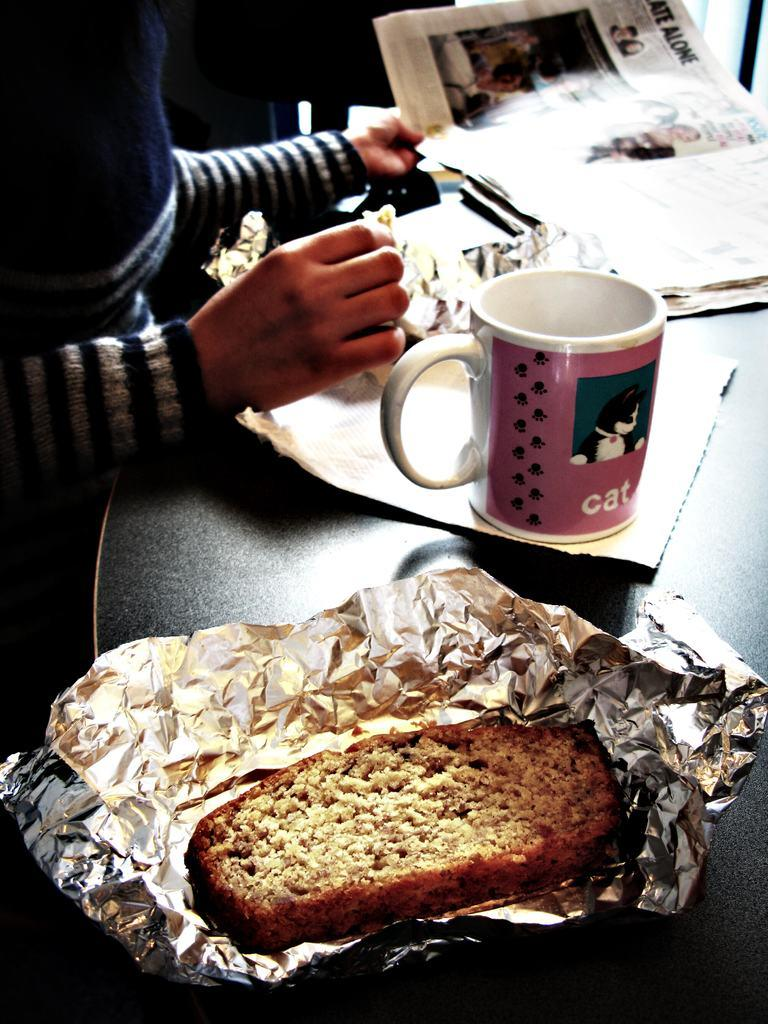Who or what is in the image? There is a person in the image. Where is the person located in relation to other objects? The person is in front of a table. What can be seen on the table? There is a cup and a newspaper on the table, along with other objects. What type of shoe is the person wearing in the image? There is no information about the person's footwear in the image, so it cannot be determined. 